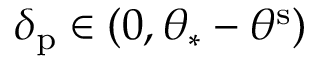Convert formula to latex. <formula><loc_0><loc_0><loc_500><loc_500>\delta _ { p } \in ( 0 , \theta _ { \ast } - \theta ^ { s } )</formula> 